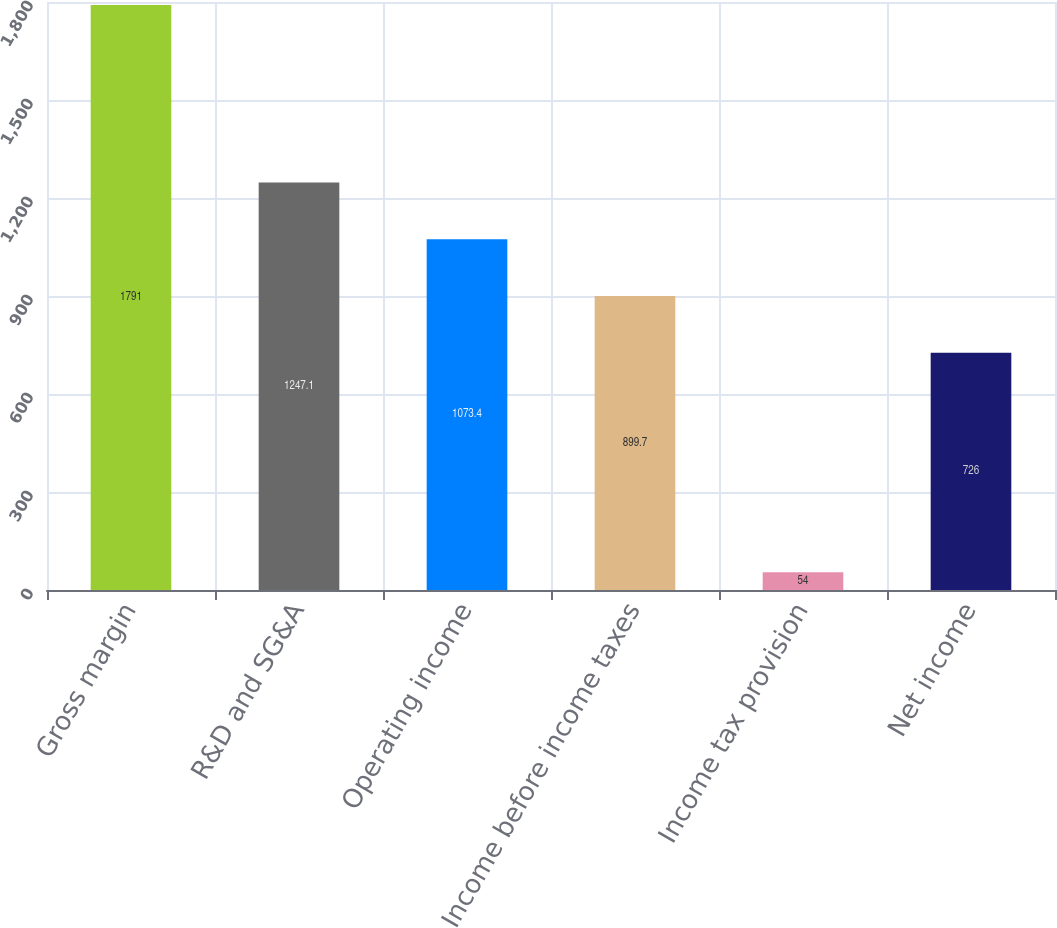<chart> <loc_0><loc_0><loc_500><loc_500><bar_chart><fcel>Gross margin<fcel>R&D and SG&A<fcel>Operating income<fcel>Income before income taxes<fcel>Income tax provision<fcel>Net income<nl><fcel>1791<fcel>1247.1<fcel>1073.4<fcel>899.7<fcel>54<fcel>726<nl></chart> 